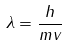<formula> <loc_0><loc_0><loc_500><loc_500>\lambda = { \frac { h } { m v } }</formula> 